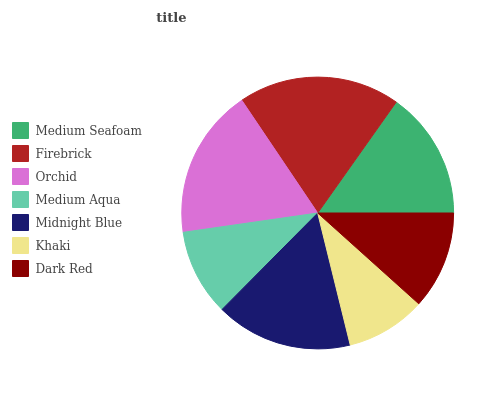Is Khaki the minimum?
Answer yes or no. Yes. Is Firebrick the maximum?
Answer yes or no. Yes. Is Orchid the minimum?
Answer yes or no. No. Is Orchid the maximum?
Answer yes or no. No. Is Firebrick greater than Orchid?
Answer yes or no. Yes. Is Orchid less than Firebrick?
Answer yes or no. Yes. Is Orchid greater than Firebrick?
Answer yes or no. No. Is Firebrick less than Orchid?
Answer yes or no. No. Is Medium Seafoam the high median?
Answer yes or no. Yes. Is Medium Seafoam the low median?
Answer yes or no. Yes. Is Orchid the high median?
Answer yes or no. No. Is Medium Aqua the low median?
Answer yes or no. No. 